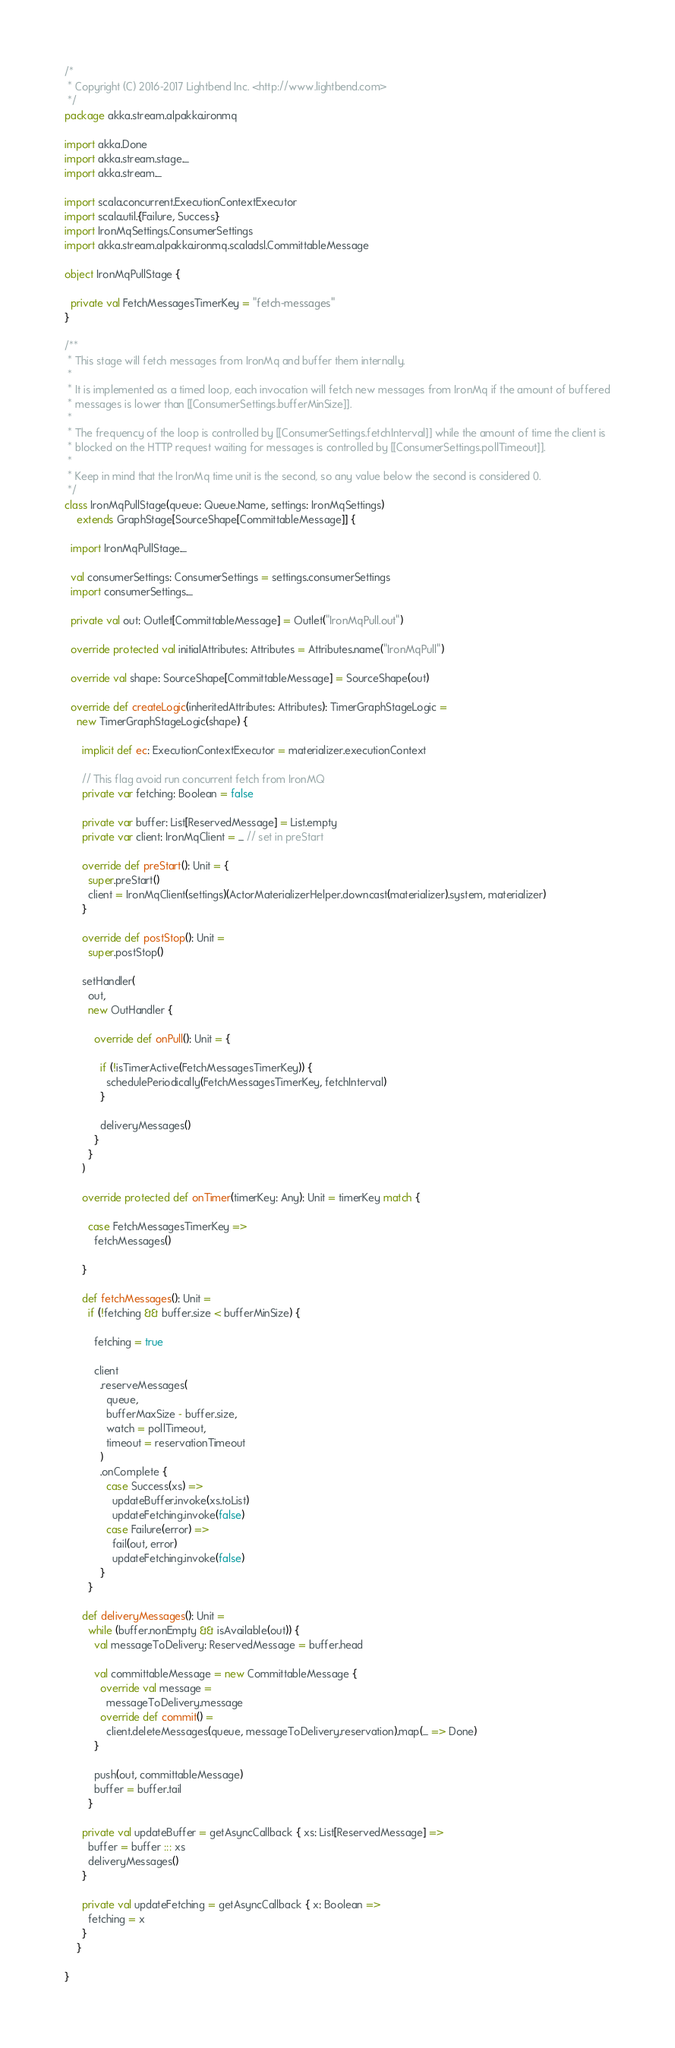Convert code to text. <code><loc_0><loc_0><loc_500><loc_500><_Scala_>/*
 * Copyright (C) 2016-2017 Lightbend Inc. <http://www.lightbend.com>
 */
package akka.stream.alpakka.ironmq

import akka.Done
import akka.stream.stage._
import akka.stream._

import scala.concurrent.ExecutionContextExecutor
import scala.util.{Failure, Success}
import IronMqSettings.ConsumerSettings
import akka.stream.alpakka.ironmq.scaladsl.CommittableMessage

object IronMqPullStage {

  private val FetchMessagesTimerKey = "fetch-messages"
}

/**
 * This stage will fetch messages from IronMq and buffer them internally.
 *
 * It is implemented as a timed loop, each invocation will fetch new messages from IronMq if the amount of buffered
 * messages is lower than [[ConsumerSettings.bufferMinSize]].
 *
 * The frequency of the loop is controlled by [[ConsumerSettings.fetchInterval]] while the amount of time the client is
 * blocked on the HTTP request waiting for messages is controlled by [[ConsumerSettings.pollTimeout]].
 *
 * Keep in mind that the IronMq time unit is the second, so any value below the second is considered 0.
 */
class IronMqPullStage(queue: Queue.Name, settings: IronMqSettings)
    extends GraphStage[SourceShape[CommittableMessage]] {

  import IronMqPullStage._

  val consumerSettings: ConsumerSettings = settings.consumerSettings
  import consumerSettings._

  private val out: Outlet[CommittableMessage] = Outlet("IronMqPull.out")

  override protected val initialAttributes: Attributes = Attributes.name("IronMqPull")

  override val shape: SourceShape[CommittableMessage] = SourceShape(out)

  override def createLogic(inheritedAttributes: Attributes): TimerGraphStageLogic =
    new TimerGraphStageLogic(shape) {

      implicit def ec: ExecutionContextExecutor = materializer.executionContext

      // This flag avoid run concurrent fetch from IronMQ
      private var fetching: Boolean = false

      private var buffer: List[ReservedMessage] = List.empty
      private var client: IronMqClient = _ // set in preStart

      override def preStart(): Unit = {
        super.preStart()
        client = IronMqClient(settings)(ActorMaterializerHelper.downcast(materializer).system, materializer)
      }

      override def postStop(): Unit =
        super.postStop()

      setHandler(
        out,
        new OutHandler {

          override def onPull(): Unit = {

            if (!isTimerActive(FetchMessagesTimerKey)) {
              schedulePeriodically(FetchMessagesTimerKey, fetchInterval)
            }

            deliveryMessages()
          }
        }
      )

      override protected def onTimer(timerKey: Any): Unit = timerKey match {

        case FetchMessagesTimerKey =>
          fetchMessages()

      }

      def fetchMessages(): Unit =
        if (!fetching && buffer.size < bufferMinSize) {

          fetching = true

          client
            .reserveMessages(
              queue,
              bufferMaxSize - buffer.size,
              watch = pollTimeout,
              timeout = reservationTimeout
            )
            .onComplete {
              case Success(xs) =>
                updateBuffer.invoke(xs.toList)
                updateFetching.invoke(false)
              case Failure(error) =>
                fail(out, error)
                updateFetching.invoke(false)
            }
        }

      def deliveryMessages(): Unit =
        while (buffer.nonEmpty && isAvailable(out)) {
          val messageToDelivery: ReservedMessage = buffer.head

          val committableMessage = new CommittableMessage {
            override val message =
              messageToDelivery.message
            override def commit() =
              client.deleteMessages(queue, messageToDelivery.reservation).map(_ => Done)
          }

          push(out, committableMessage)
          buffer = buffer.tail
        }

      private val updateBuffer = getAsyncCallback { xs: List[ReservedMessage] =>
        buffer = buffer ::: xs
        deliveryMessages()
      }

      private val updateFetching = getAsyncCallback { x: Boolean =>
        fetching = x
      }
    }

}
</code> 